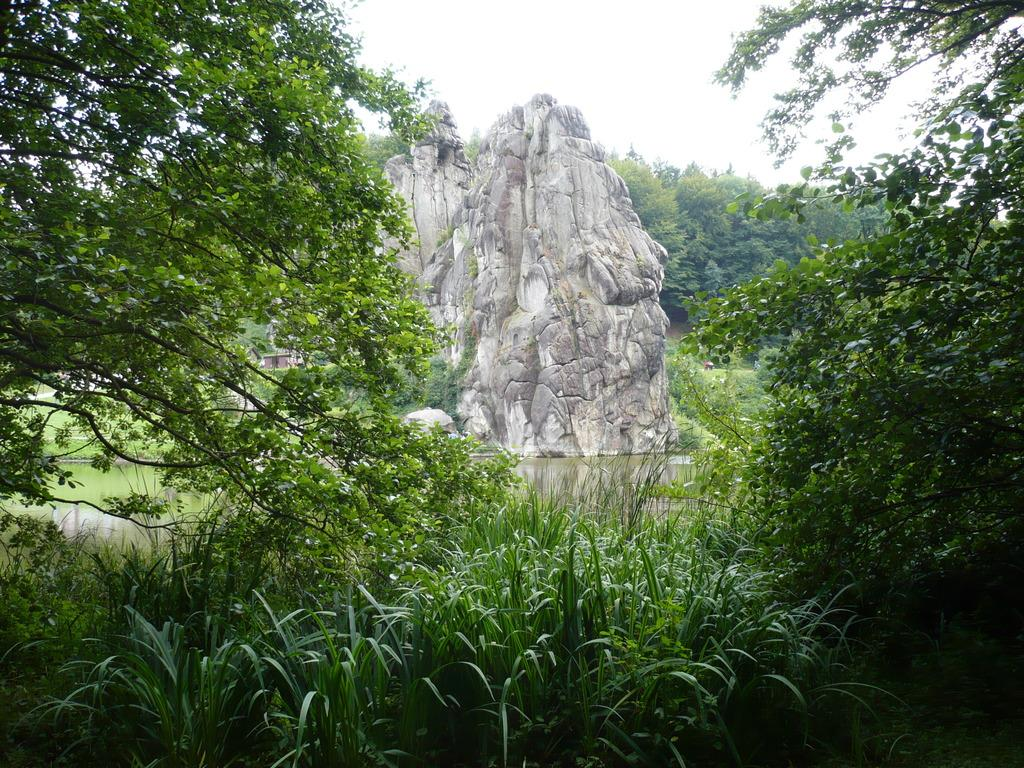What type of natural elements can be seen in the image? There are rocks, water, trees, and bushes visible in the image. What part of the natural environment is not visible in the image? The ground is not visible in the image. What is visible in the sky in the image? The sky is visible in the image. How many yaks are grazing in the image? There are no yaks present in the image. What type of sorting algorithm is being used by the trees in the image? Trees do not use sorting algorithms; they are living organisms that grow and reproduce. 